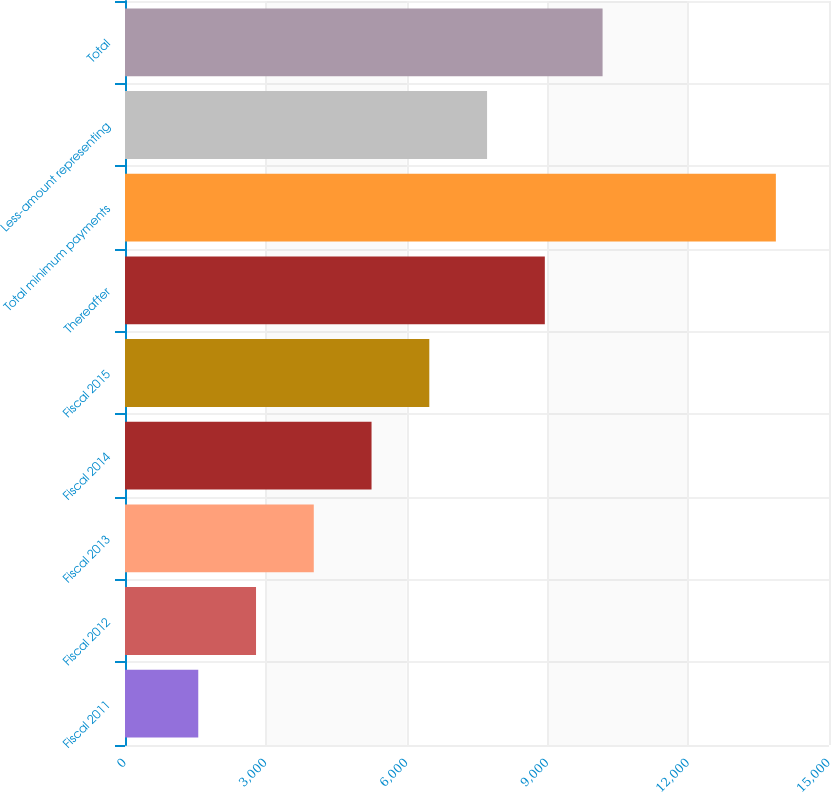Convert chart. <chart><loc_0><loc_0><loc_500><loc_500><bar_chart><fcel>Fiscal 2011<fcel>Fiscal 2012<fcel>Fiscal 2013<fcel>Fiscal 2014<fcel>Fiscal 2015<fcel>Thereafter<fcel>Total minimum payments<fcel>Less-amount representing<fcel>Total<nl><fcel>1561<fcel>2791.7<fcel>4022.4<fcel>5253.1<fcel>6483.8<fcel>8945.2<fcel>13868<fcel>7714.5<fcel>10175.9<nl></chart> 